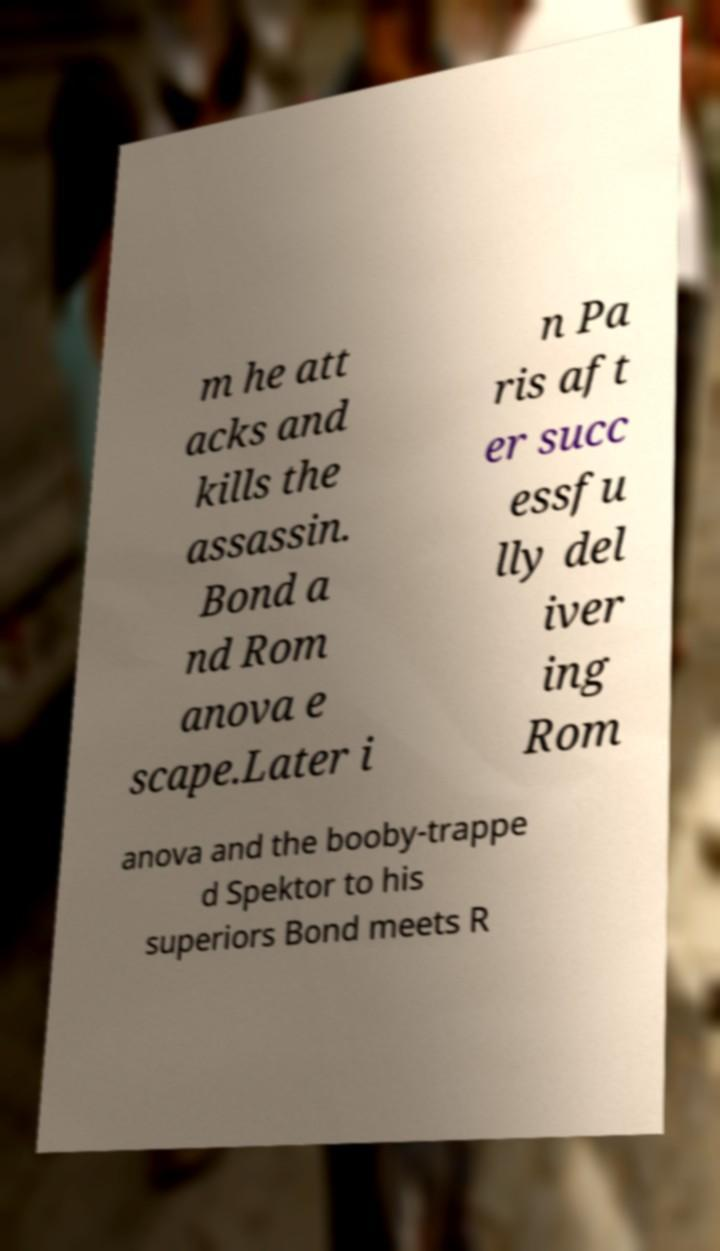There's text embedded in this image that I need extracted. Can you transcribe it verbatim? m he att acks and kills the assassin. Bond a nd Rom anova e scape.Later i n Pa ris aft er succ essfu lly del iver ing Rom anova and the booby-trappe d Spektor to his superiors Bond meets R 